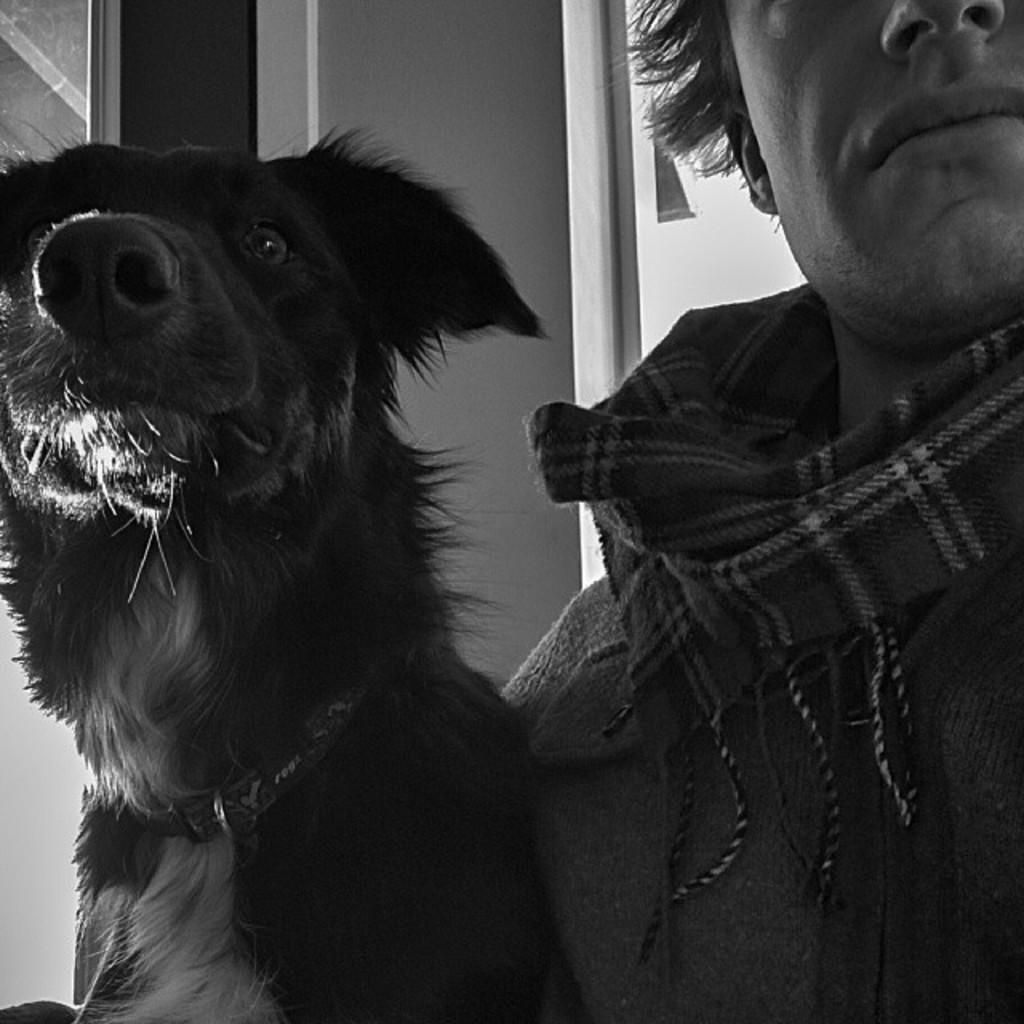What is the color scheme of the image? The image is black and white. Can you describe the subjects in the image? There is a person and a dog in the image. How many mittens can be seen in the image? There are no mittens present in the image. What type of eggs are being cooked in the image? There are no eggs or cooking activity depicted in the image. 